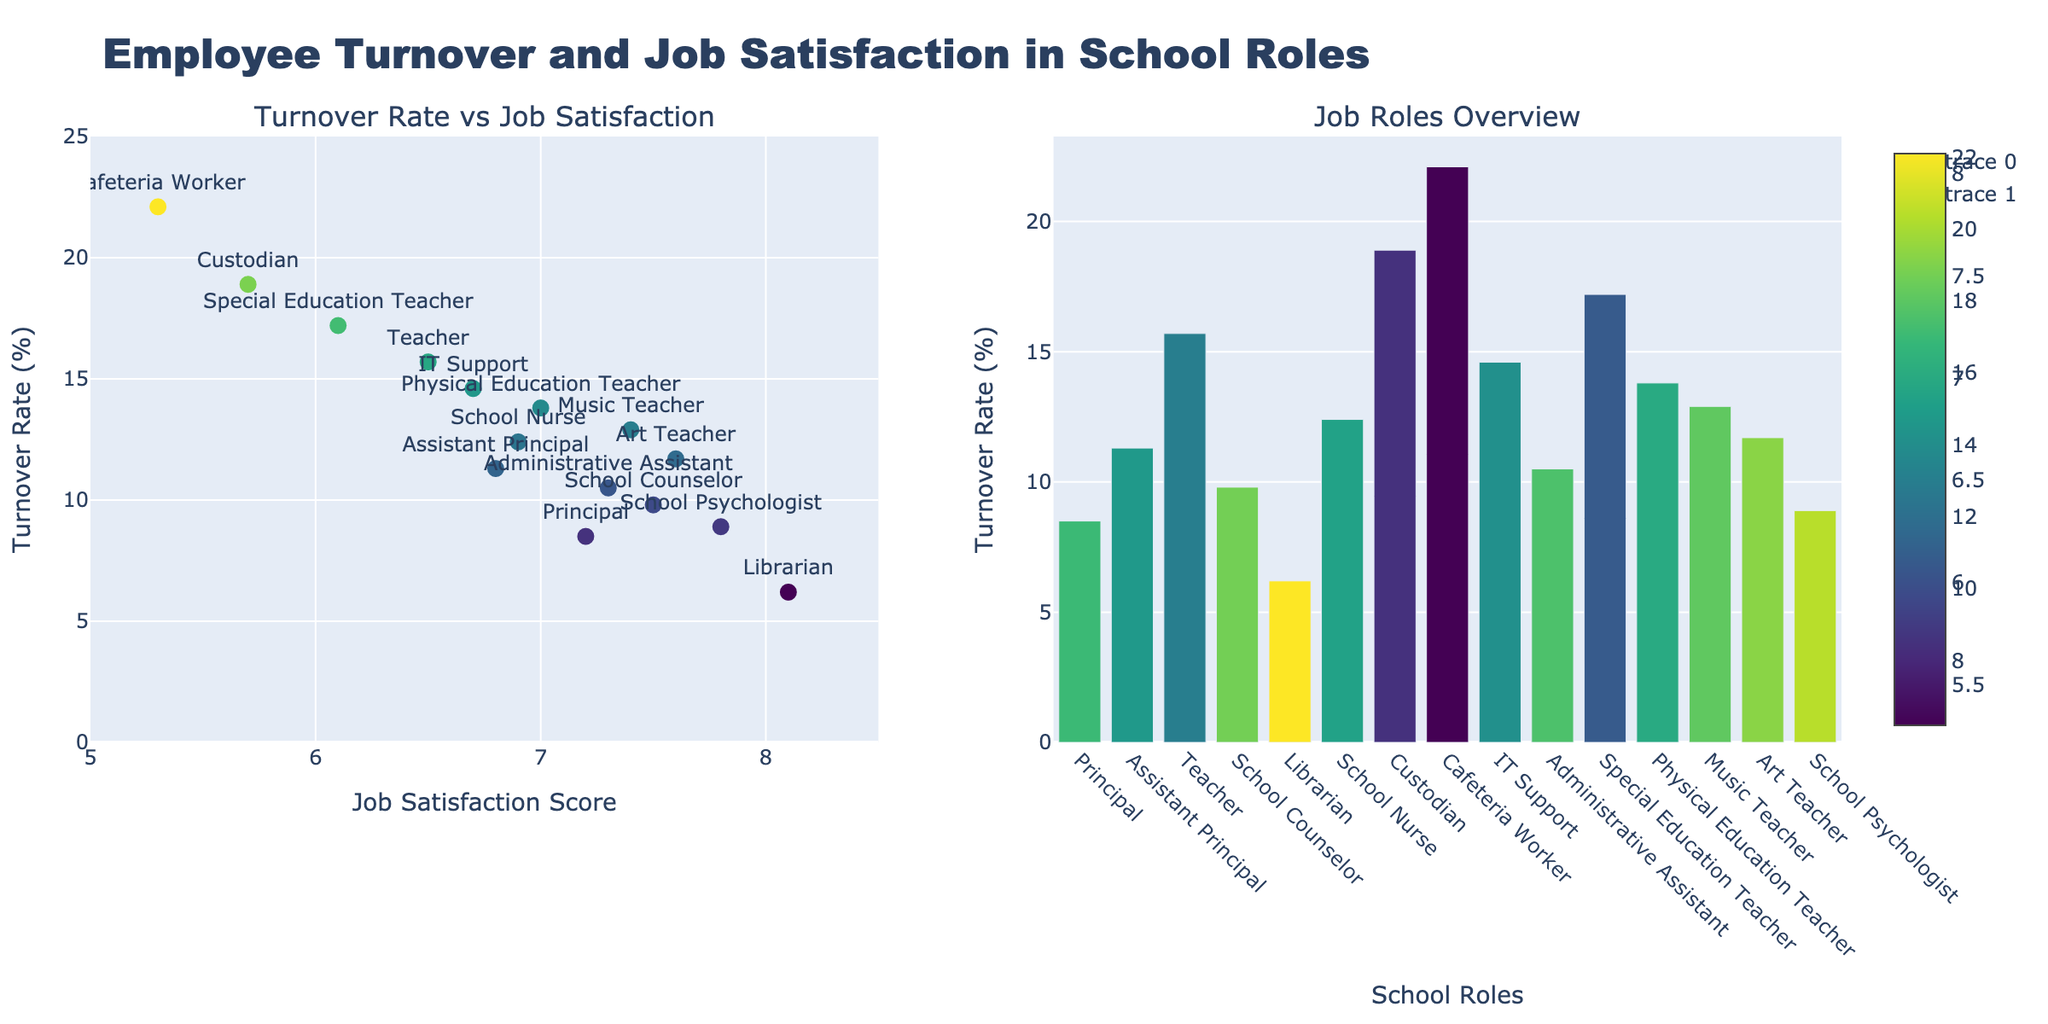What's the title of the figure? The title is displayed prominently at the top of the figure and reads "Employee Turnover and Job Satisfaction in School Roles".
Answer: Employee Turnover and Job Satisfaction in School Roles How many school roles are depicted in the scatter plot on the left? Each point in the scatter plot represents a school role, and there are 15 points shown.
Answer: 15 Which role has the highest turnover rate? By examining the y-axis in both plots, the role with the highest point on the turnover rate is the Cafeteria Worker at 22.1%.
Answer: Cafeteria Worker What is the job satisfaction score of the role with the lowest turnover rate? On the left scatter plot, the role with the lowest point on the turnover rate is the Librarian with 6.2%, and on the x-axis, the job satisfaction score for the Librarian is 8.1.
Answer: 8.1 Which role has a higher turnover rate: Physical Education Teacher or Special Education Teacher? By comparing the heights of the bars or points in both the scatter plot and bar plot, the turnover rate for Physical Education Teacher is 13.8%, and for Special Education Teacher, it is 17.2%.
Answer: Special Education Teacher What is the average turnover rate of roles with a job satisfaction score above 7.0? Identify roles with job satisfaction > 7.0 (Principal, School Counselor, Librarian, Administrative Assistant, Music Teacher, Art Teacher, School Psychologist), and calculate the average of their turnover rates: (8.5 + 9.8 + 6.2 + 10.5 + 12.9 + 11.7 + 8.9) / 7 = 9.36%.
Answer: 9.36% Which role shows an unusual pattern of having a relatively high job satisfaction but also a high turnover rate? Observing the scatter plot, most roles with high job satisfaction have low turnover rates, except for Music Teacher with a satisfaction of 7.4 but a turnover rate of 12.9%.
Answer: Music Teacher How does the turnover rate of IT Support compare to the average turnover rate of all roles? The turnover rate for IT Support is 14.6%. To find the average turnover rate across all roles, sum all turnover rates and divide by 15: (8.5 + 11.3 + 15.7 + 9.8 + 6.2 + 12.4 + 18.9 + 22.1 + 14.6 + 10.5 + 17.2 + 13.8 + 12.9 + 11.7 + 8.9) / 15 = 12.8%.
Answer: Higher What does the colorscale represent in both subplots? The colorscale in both the scatter and bar plots represents the job satisfaction scores, with color intensities varying based on satisfaction levels.
Answer: Job satisfaction scores 